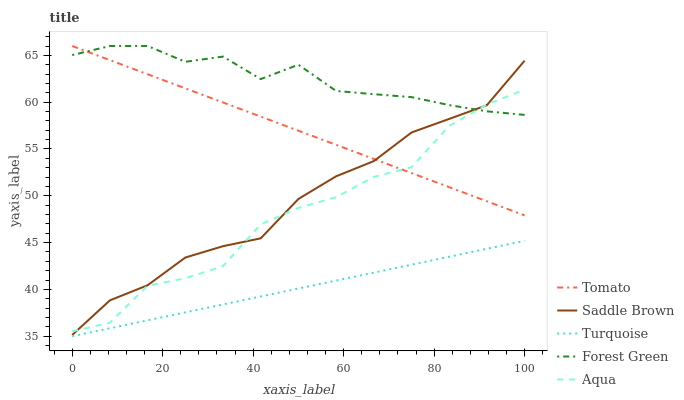Does Turquoise have the minimum area under the curve?
Answer yes or no. Yes. Does Forest Green have the maximum area under the curve?
Answer yes or no. Yes. Does Aqua have the minimum area under the curve?
Answer yes or no. No. Does Aqua have the maximum area under the curve?
Answer yes or no. No. Is Turquoise the smoothest?
Answer yes or no. Yes. Is Aqua the roughest?
Answer yes or no. Yes. Is Aqua the smoothest?
Answer yes or no. No. Is Turquoise the roughest?
Answer yes or no. No. Does Turquoise have the lowest value?
Answer yes or no. Yes. Does Aqua have the lowest value?
Answer yes or no. No. Does Forest Green have the highest value?
Answer yes or no. Yes. Does Aqua have the highest value?
Answer yes or no. No. Is Turquoise less than Aqua?
Answer yes or no. Yes. Is Aqua greater than Turquoise?
Answer yes or no. Yes. Does Aqua intersect Saddle Brown?
Answer yes or no. Yes. Is Aqua less than Saddle Brown?
Answer yes or no. No. Is Aqua greater than Saddle Brown?
Answer yes or no. No. Does Turquoise intersect Aqua?
Answer yes or no. No. 